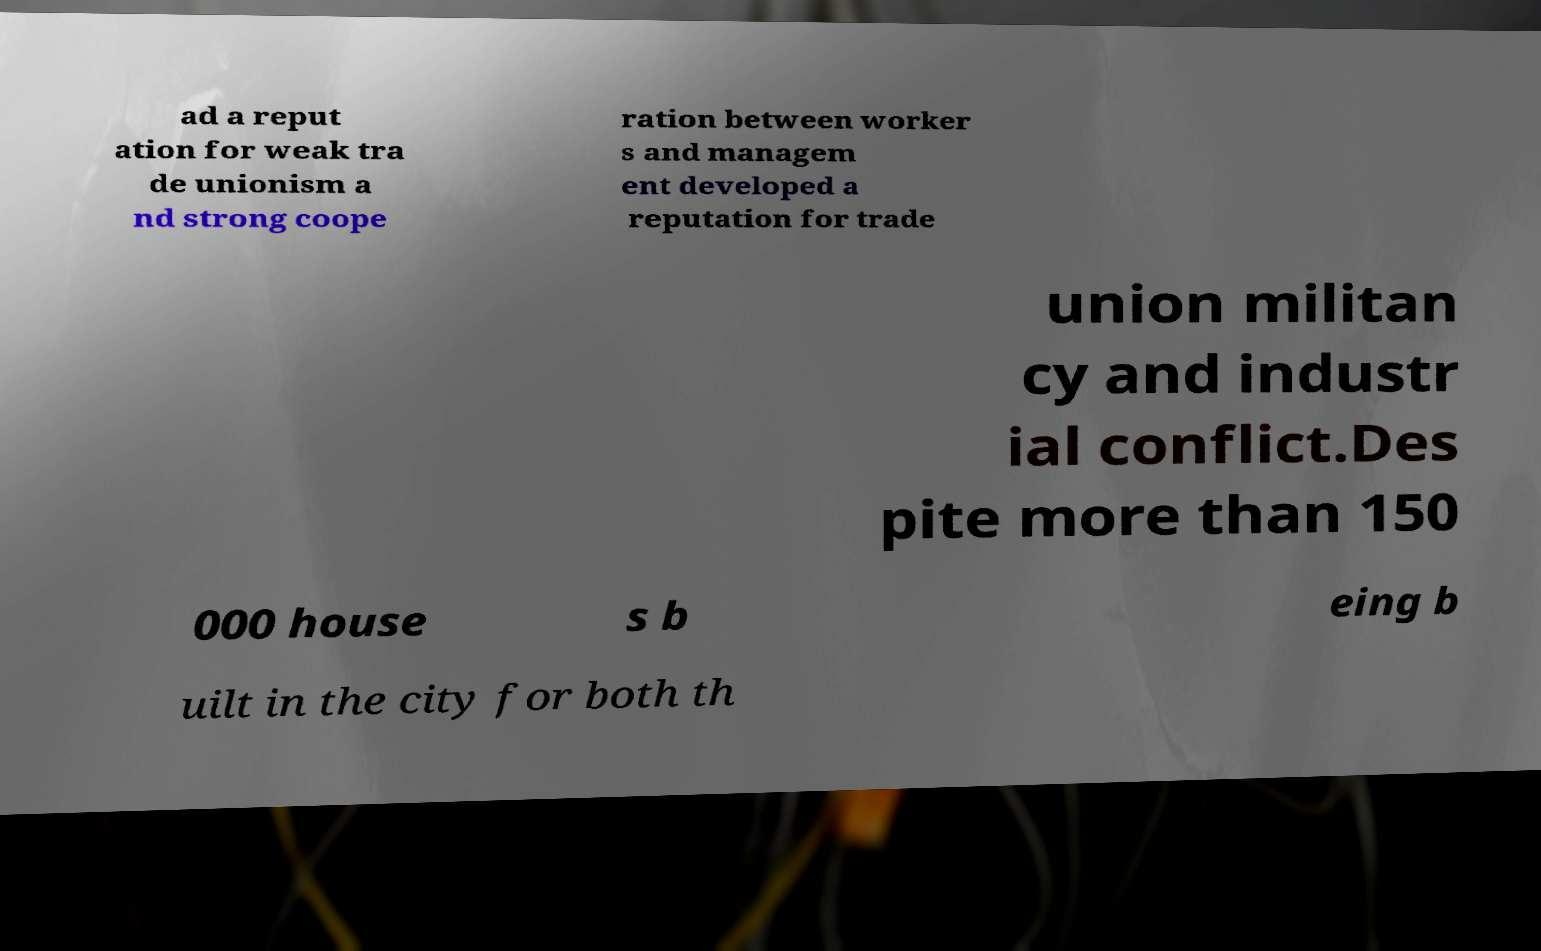Please identify and transcribe the text found in this image. ad a reput ation for weak tra de unionism a nd strong coope ration between worker s and managem ent developed a reputation for trade union militan cy and industr ial conflict.Des pite more than 150 000 house s b eing b uilt in the city for both th 